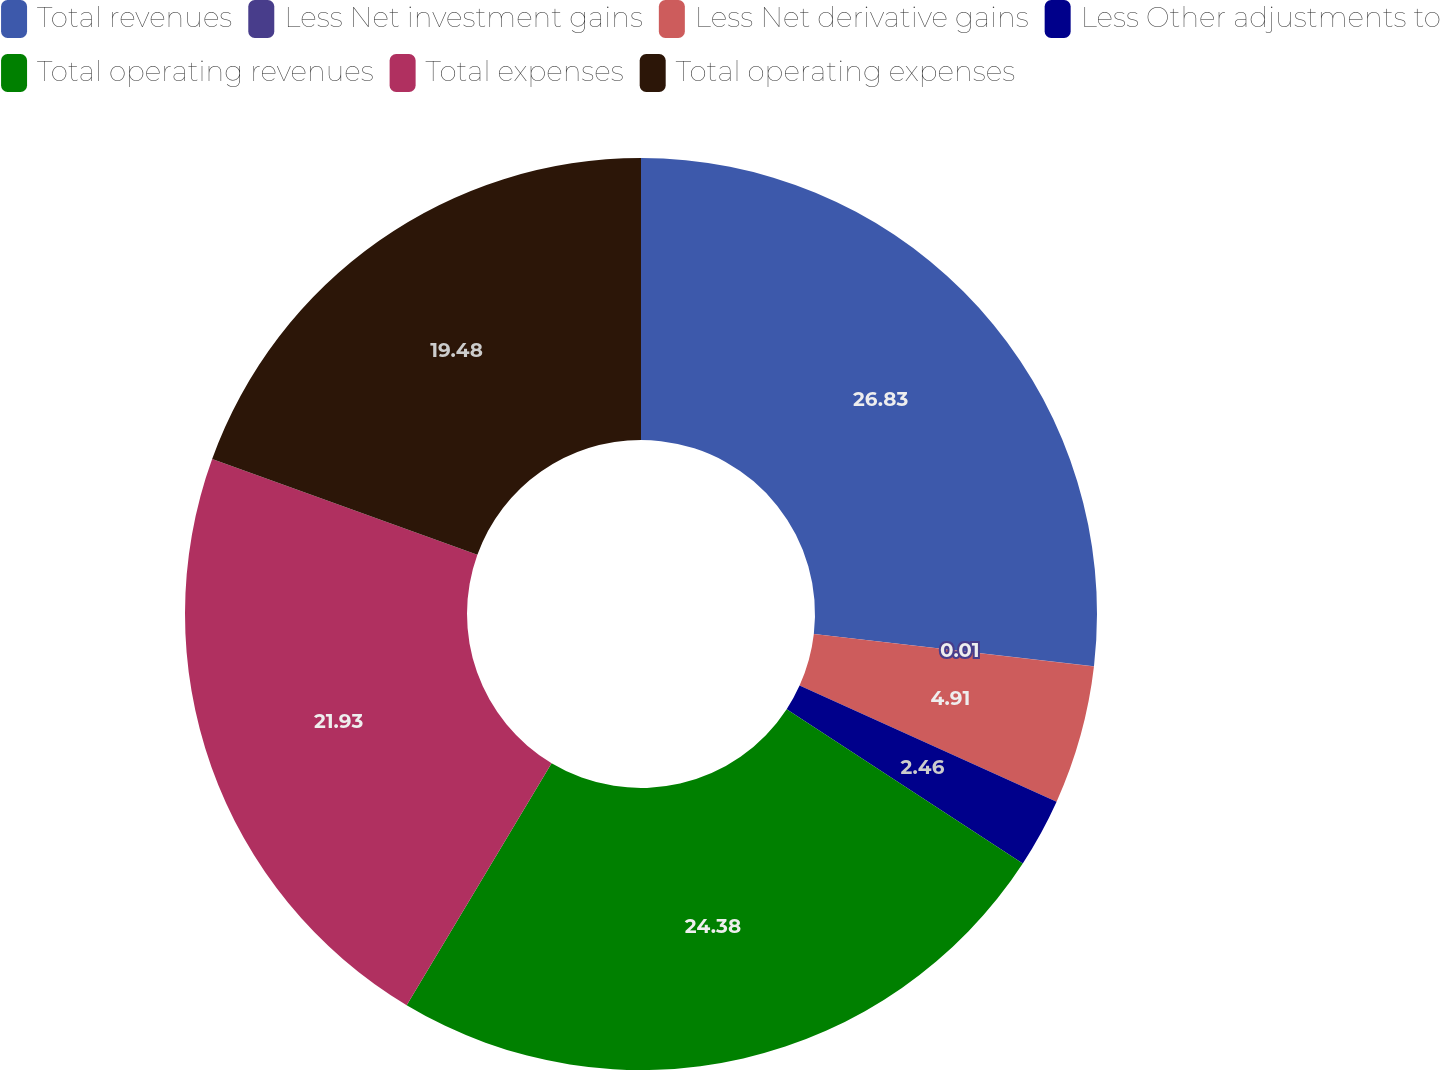Convert chart to OTSL. <chart><loc_0><loc_0><loc_500><loc_500><pie_chart><fcel>Total revenues<fcel>Less Net investment gains<fcel>Less Net derivative gains<fcel>Less Other adjustments to<fcel>Total operating revenues<fcel>Total expenses<fcel>Total operating expenses<nl><fcel>26.83%<fcel>0.01%<fcel>4.91%<fcel>2.46%<fcel>24.38%<fcel>21.93%<fcel>19.48%<nl></chart> 